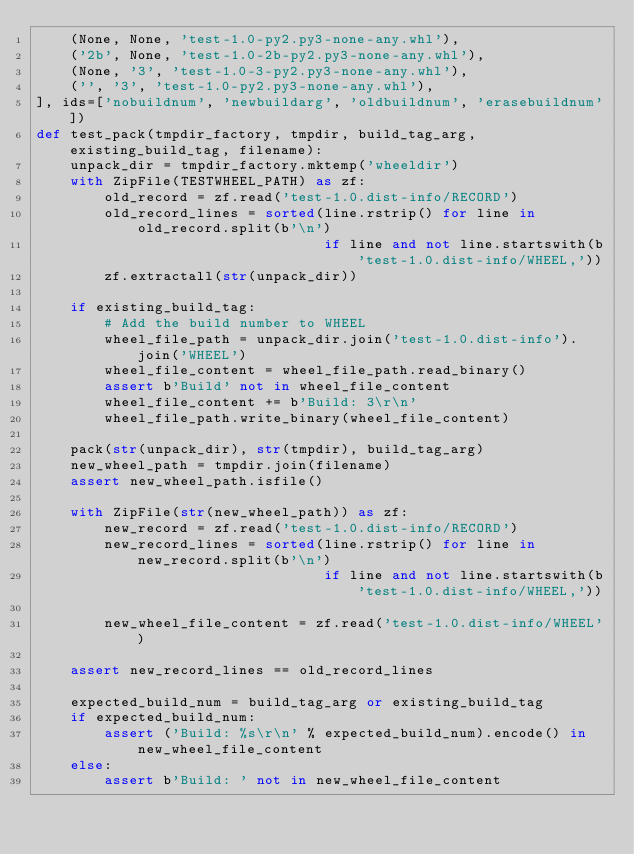<code> <loc_0><loc_0><loc_500><loc_500><_Python_>    (None, None, 'test-1.0-py2.py3-none-any.whl'),
    ('2b', None, 'test-1.0-2b-py2.py3-none-any.whl'),
    (None, '3', 'test-1.0-3-py2.py3-none-any.whl'),
    ('', '3', 'test-1.0-py2.py3-none-any.whl'),
], ids=['nobuildnum', 'newbuildarg', 'oldbuildnum', 'erasebuildnum'])
def test_pack(tmpdir_factory, tmpdir, build_tag_arg, existing_build_tag, filename):
    unpack_dir = tmpdir_factory.mktemp('wheeldir')
    with ZipFile(TESTWHEEL_PATH) as zf:
        old_record = zf.read('test-1.0.dist-info/RECORD')
        old_record_lines = sorted(line.rstrip() for line in old_record.split(b'\n')
                                  if line and not line.startswith(b'test-1.0.dist-info/WHEEL,'))
        zf.extractall(str(unpack_dir))

    if existing_build_tag:
        # Add the build number to WHEEL
        wheel_file_path = unpack_dir.join('test-1.0.dist-info').join('WHEEL')
        wheel_file_content = wheel_file_path.read_binary()
        assert b'Build' not in wheel_file_content
        wheel_file_content += b'Build: 3\r\n'
        wheel_file_path.write_binary(wheel_file_content)

    pack(str(unpack_dir), str(tmpdir), build_tag_arg)
    new_wheel_path = tmpdir.join(filename)
    assert new_wheel_path.isfile()

    with ZipFile(str(new_wheel_path)) as zf:
        new_record = zf.read('test-1.0.dist-info/RECORD')
        new_record_lines = sorted(line.rstrip() for line in new_record.split(b'\n')
                                  if line and not line.startswith(b'test-1.0.dist-info/WHEEL,'))

        new_wheel_file_content = zf.read('test-1.0.dist-info/WHEEL')

    assert new_record_lines == old_record_lines

    expected_build_num = build_tag_arg or existing_build_tag
    if expected_build_num:
        assert ('Build: %s\r\n' % expected_build_num).encode() in new_wheel_file_content
    else:
        assert b'Build: ' not in new_wheel_file_content
</code> 